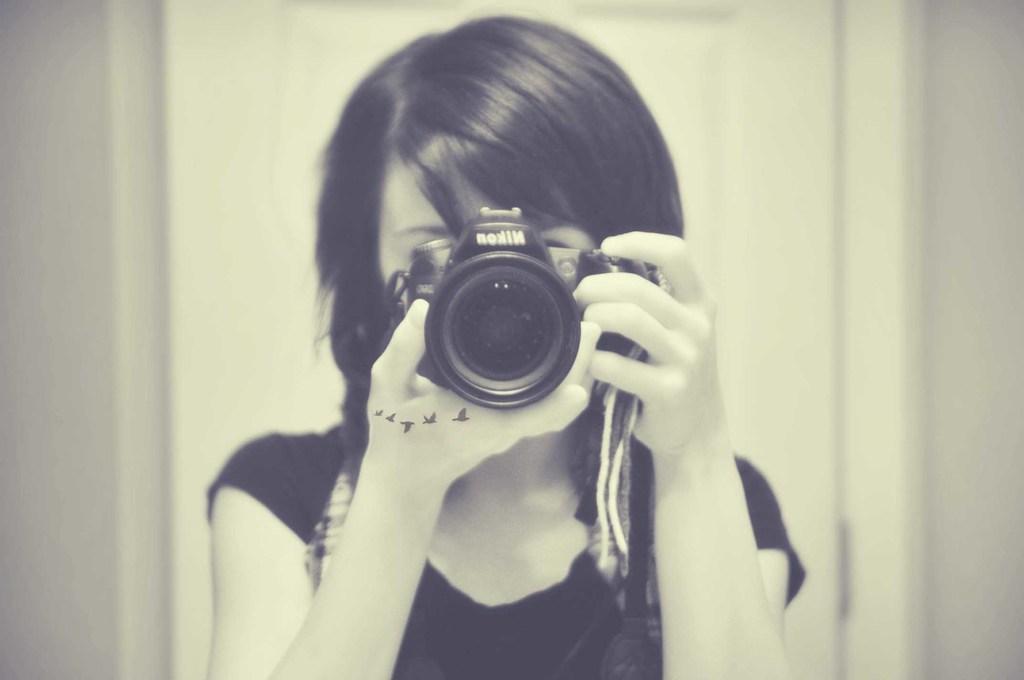Describe this image in one or two sentences. In this image I can see the person holding a camera and the person is wearing black color dress and I can see white color background. 